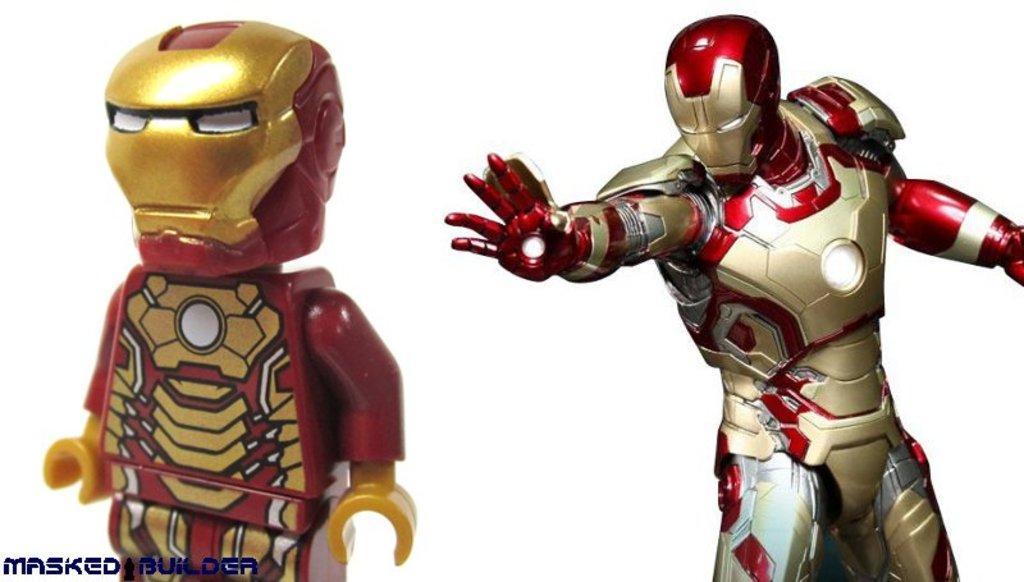Could you give a brief overview of what you see in this image? In the image there are two toys, both the toys belongs to a same category. 